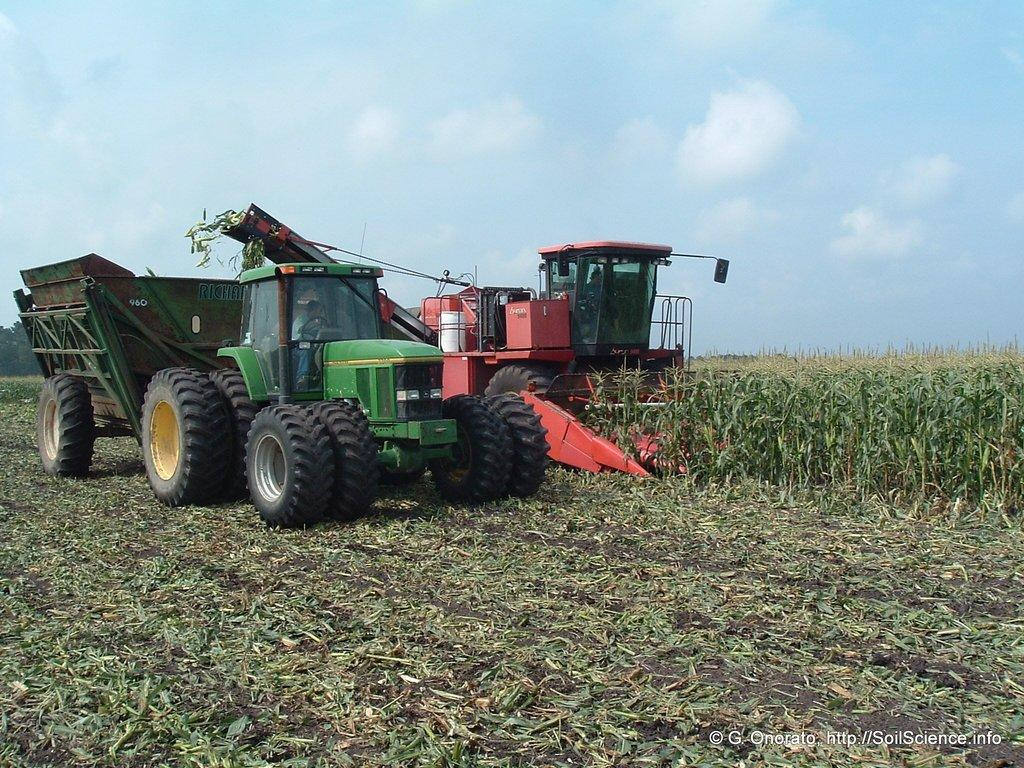What types of objects can be seen in the image? There are vehicles and plants in the image. Can you describe the sky in the background of the image? The sky in the background of the image has clouds visible. How does the bat fly through the image? There is no bat present in the image; it only features vehicles, plants, and clouds in the sky. 